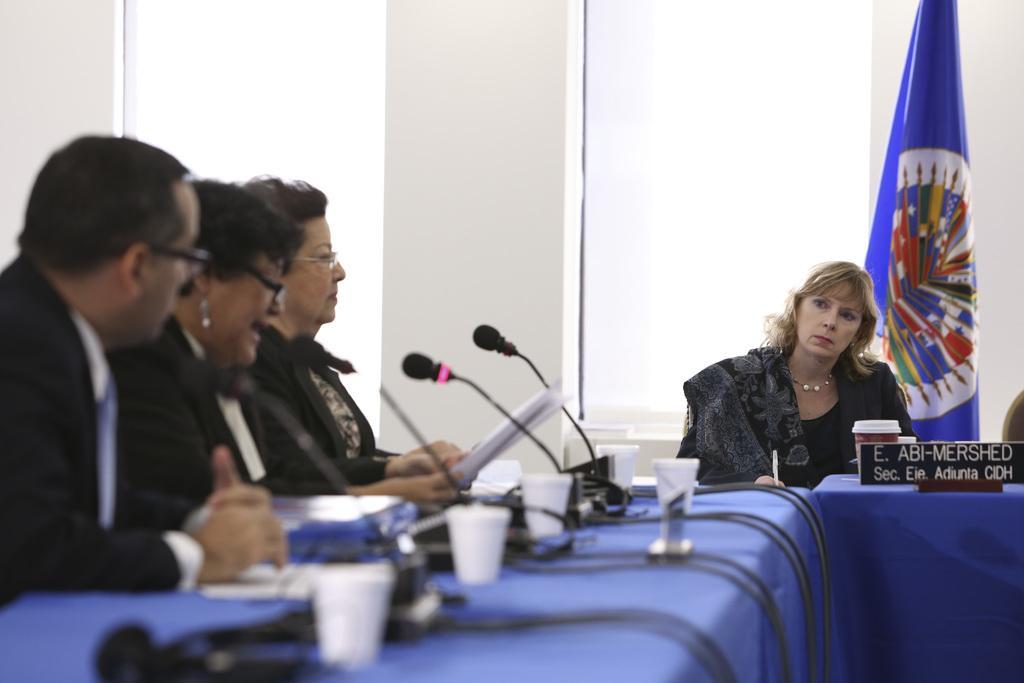Could you give a brief overview of what you see in this image? In the picture, it looks like a meeting is going on , there is a blue color table on which some mikes , glasses and wires are held , there are three people siiting front of one table on the other side there is one woman sitting there is also a name board on that table in the background there is a blue color flag, a window and white color wall. 